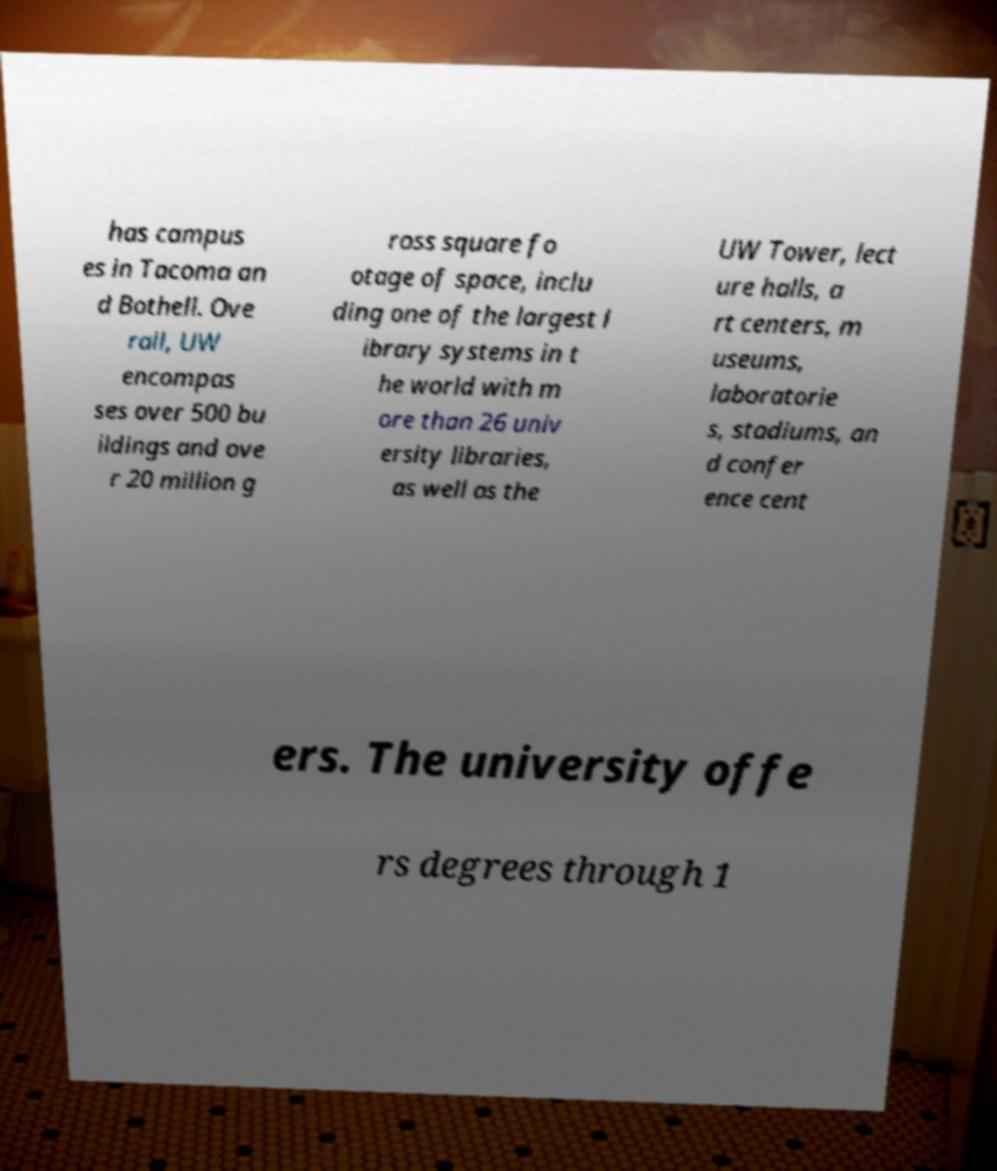Could you assist in decoding the text presented in this image and type it out clearly? has campus es in Tacoma an d Bothell. Ove rall, UW encompas ses over 500 bu ildings and ove r 20 million g ross square fo otage of space, inclu ding one of the largest l ibrary systems in t he world with m ore than 26 univ ersity libraries, as well as the UW Tower, lect ure halls, a rt centers, m useums, laboratorie s, stadiums, an d confer ence cent ers. The university offe rs degrees through 1 